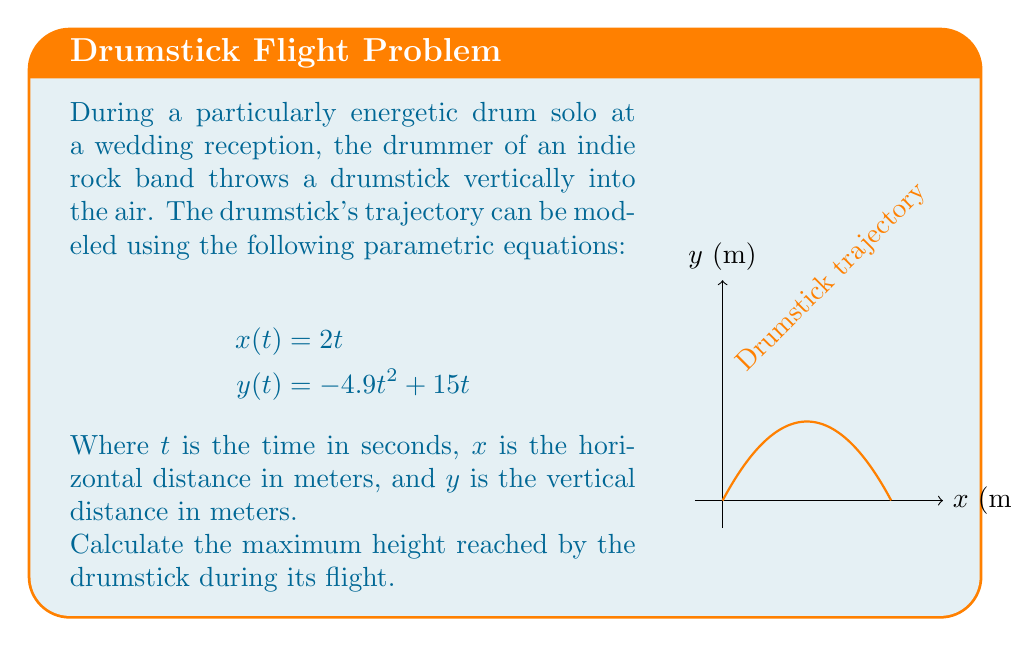Solve this math problem. To find the maximum height of the drumstick, we need to determine the highest point of the y-coordinate. This occurs when the vertical velocity is zero.

Step 1: Find the vertical velocity by differentiating y(t) with respect to t.
$$\frac{dy}{dt} = -9.8t + 15$$

Step 2: Set the vertical velocity to zero and solve for t.
$$-9.8t + 15 = 0$$
$$9.8t = 15$$
$$t = \frac{15}{9.8} \approx 1.53 \text{ seconds}$$

Step 3: Substitute this t-value back into the original y(t) equation to find the maximum height.
$$y(1.53) = -4.9(1.53)^2 + 15(1.53)$$
$$y(1.53) = -4.9(2.34) + 22.95$$
$$y(1.53) = -11.47 + 22.95$$
$$y(1.53) = 11.48 \text{ meters}$$

Therefore, the maximum height reached by the drumstick is approximately 11.48 meters.
Answer: 11.48 meters 